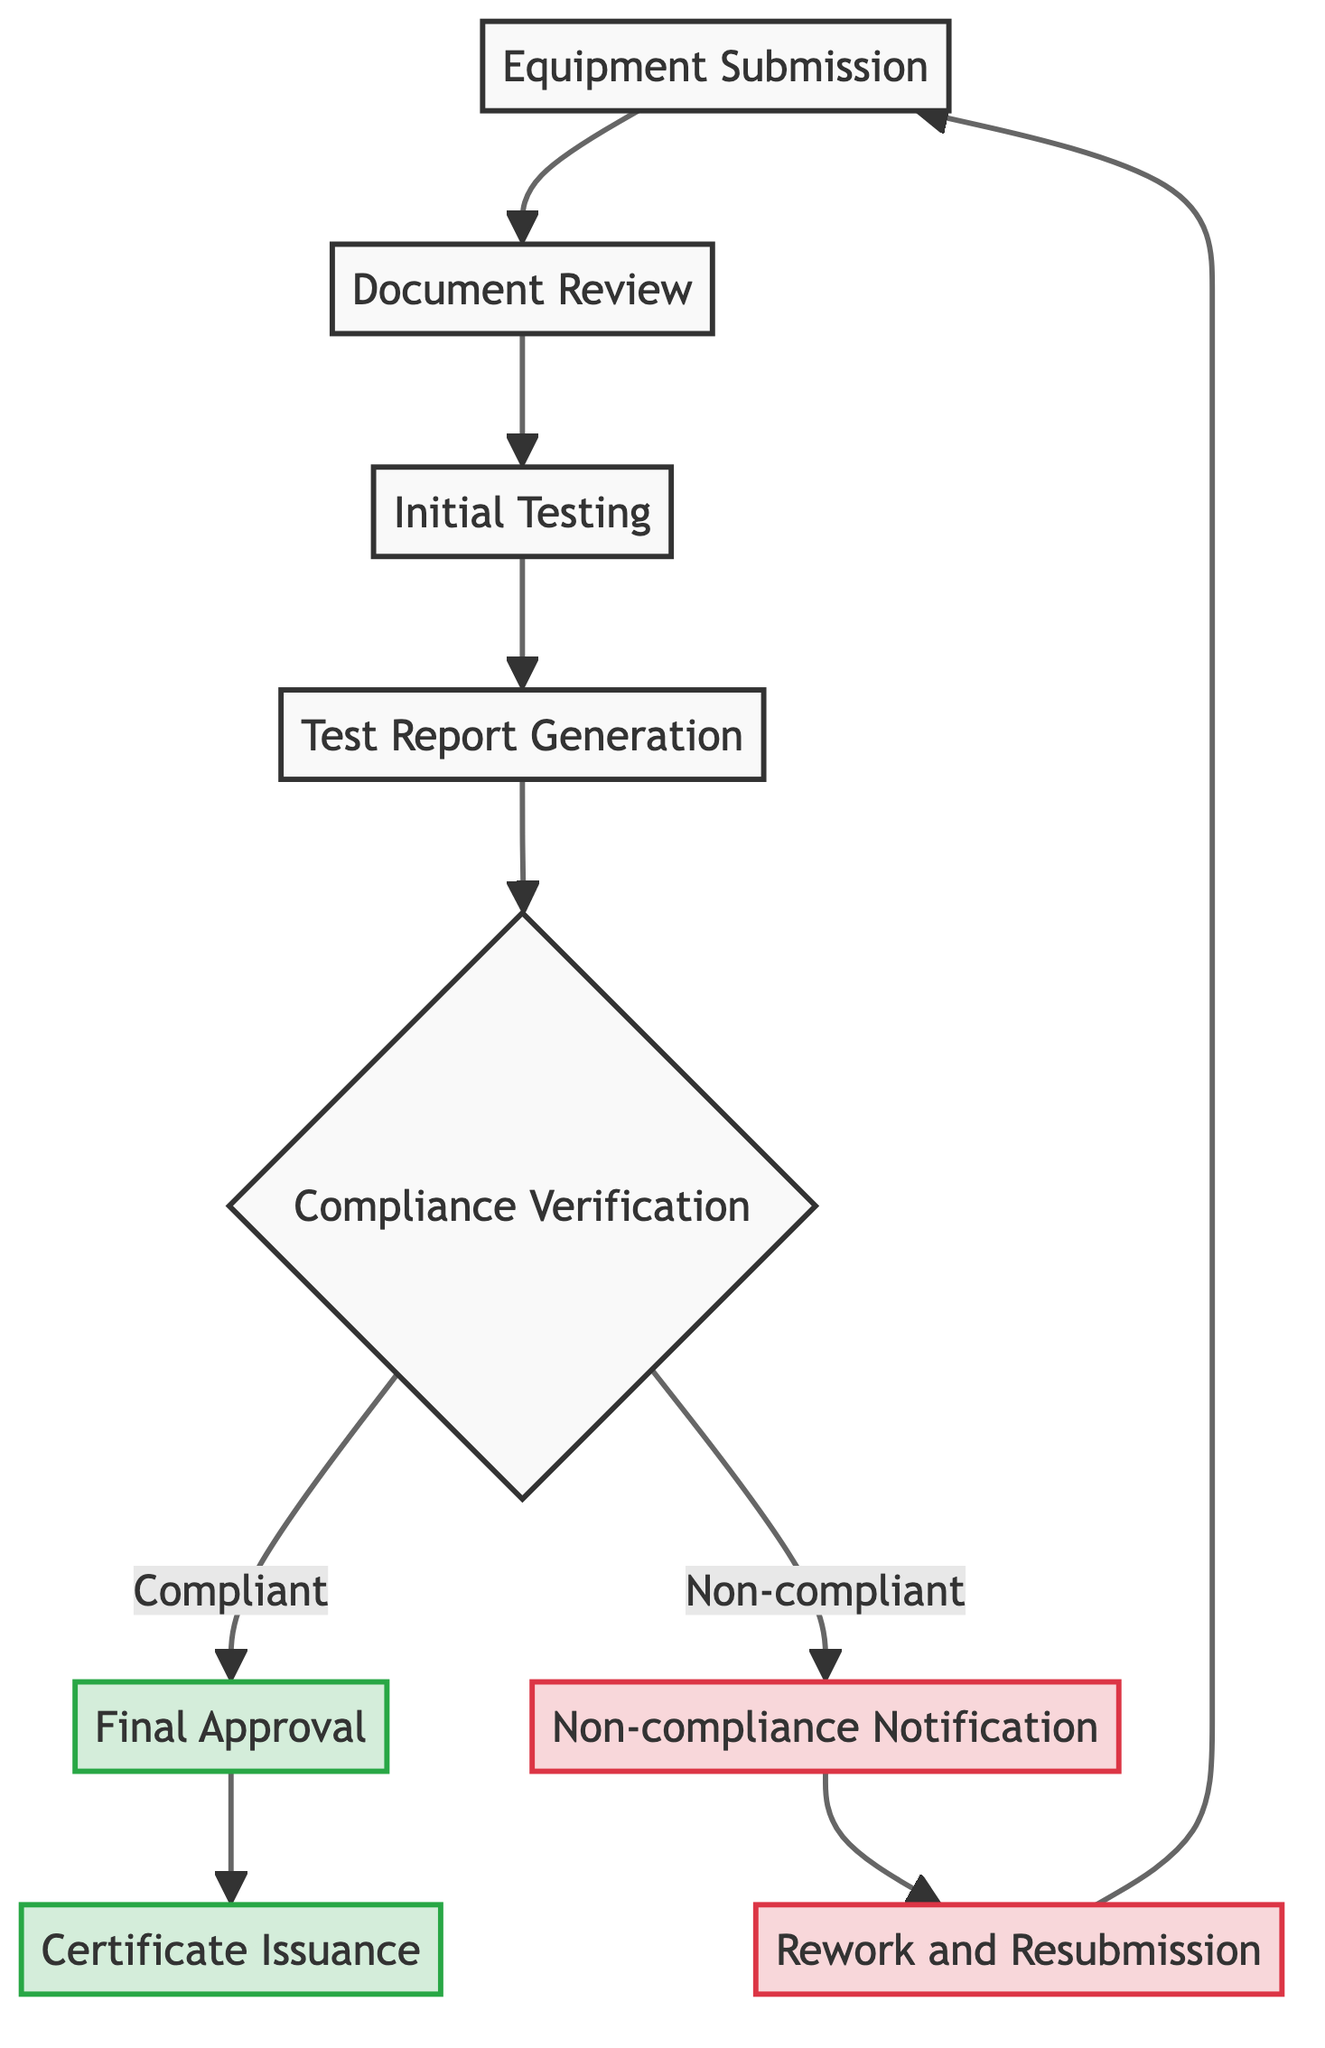What is the first step in the workflow? The first step is "Equipment Submission," as it is the starting point of the diagram and no other node precedes it.
Answer: Equipment Submission How many nodes are there in the diagram? By counting all distinct elements in the diagram, there are nine nodes listed.
Answer: 9 What does the "Initial Testing" node directly lead to? The "Initial Testing" node leads directly to the "Test Report Generation" node, as there is a direct connection from Initial Testing to Test Report Generation.
Answer: Test Report Generation What happens if the compliance verification is non-compliant? If the compliance verification results in non-compliance, the process will lead to "Non-compliance Notification," indicating that further action is necessary.
Answer: Non-compliance Notification What is generated after conducting initial tests? After conducting initial tests, "Test Report Generation" takes place, resulting in the production of a report based on those tests.
Answer: Test Report Generation How many approvals are in the workflow? There is only one approval step noted in the workflow, which is "Final Approval," occurring after the compliance verification confirms the equipment is compliant.
Answer: 1 What must occur before the "Certificate Issuance"? Before "Certificate Issuance," there must be a "Final Approval" from the regulatory authority confirming that the equipment meets all compliance standards.
Answer: Final Approval What is the outcome when equipment is compliant? If equipment is compliant, it results in "Final Approval" followed by the issuance of a certificate, indicating successful certification.
Answer: Final Approval What leads back to the "Equipment Submission" node? "Rework and Resubmission" leads back to the "Equipment Submission" node as it indicates that the equipment is submitted again after rework based on feedback.
Answer: Rework and Resubmission 